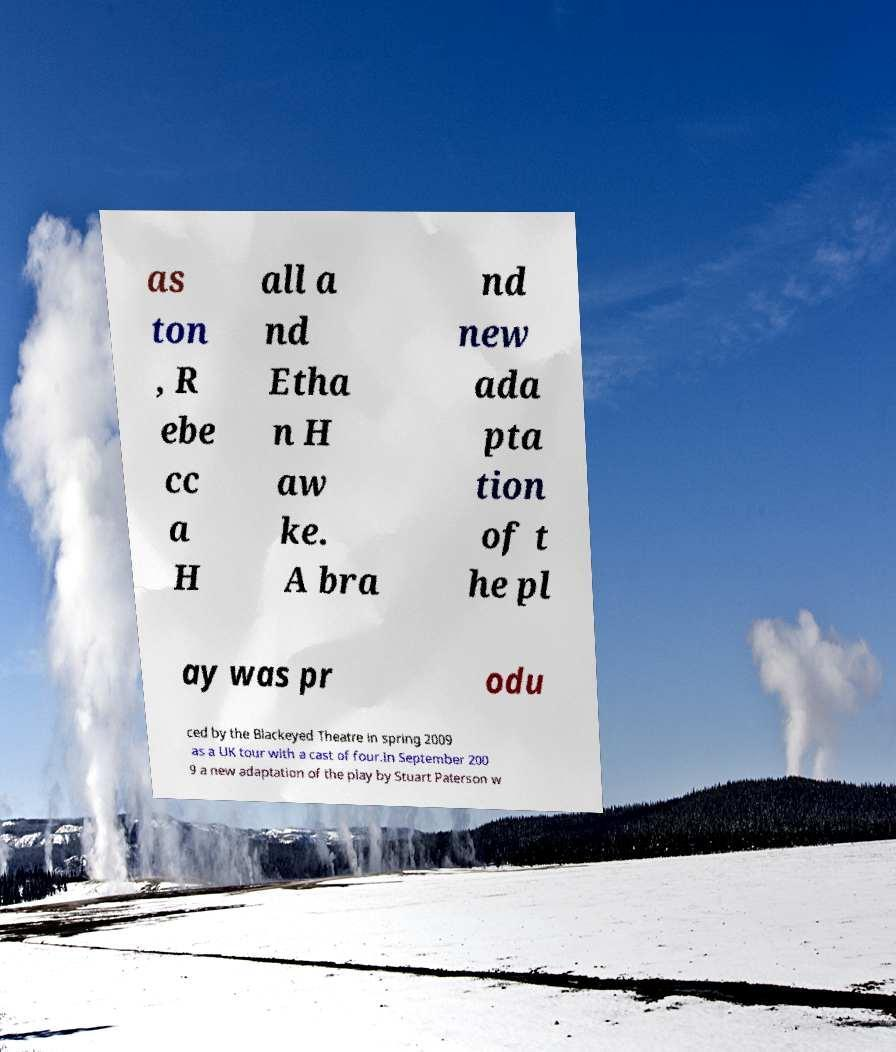There's text embedded in this image that I need extracted. Can you transcribe it verbatim? as ton , R ebe cc a H all a nd Etha n H aw ke. A bra nd new ada pta tion of t he pl ay was pr odu ced by the Blackeyed Theatre in spring 2009 as a UK tour with a cast of four.In September 200 9 a new adaptation of the play by Stuart Paterson w 